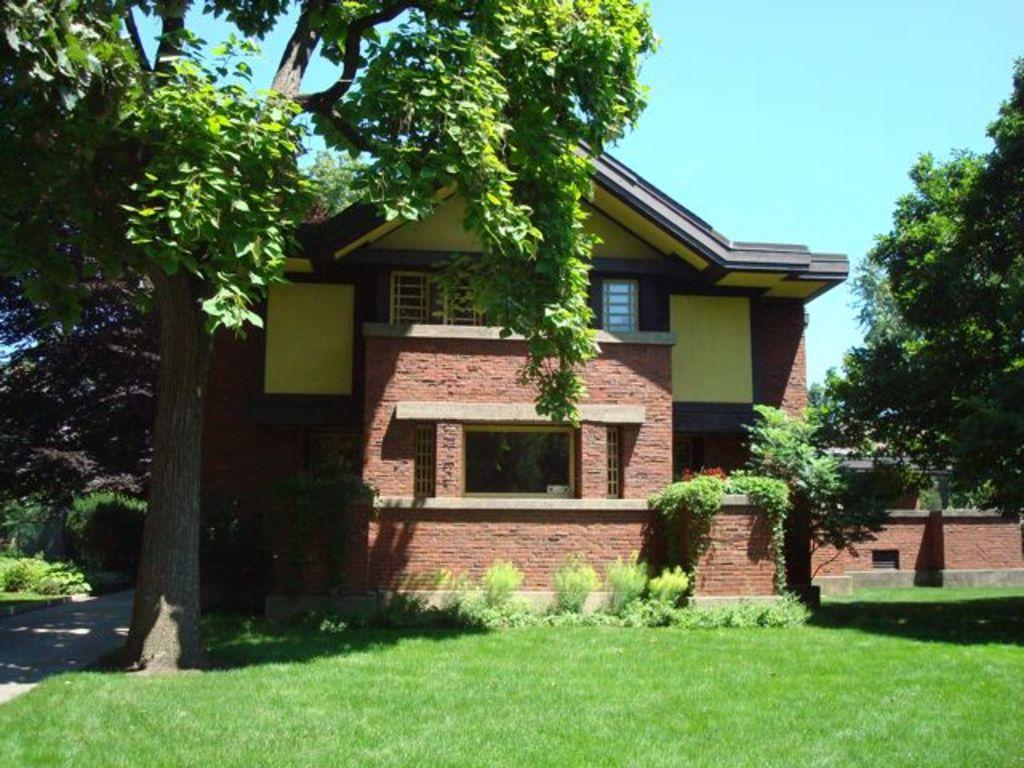What type of vegetation is present in the image? There is grass and plants in the image. What type of structure is visible in the image? There is a house in the image. What can be seen in the background of the image? There are trees and the sky visible in the background of the image. Can you tell me how many frogs are sitting on the boundary in the image? There are no frogs or boundaries present in the image. Is the rain visible in the image? There is no mention of rain in the provided facts, and it is not visible in the image. 